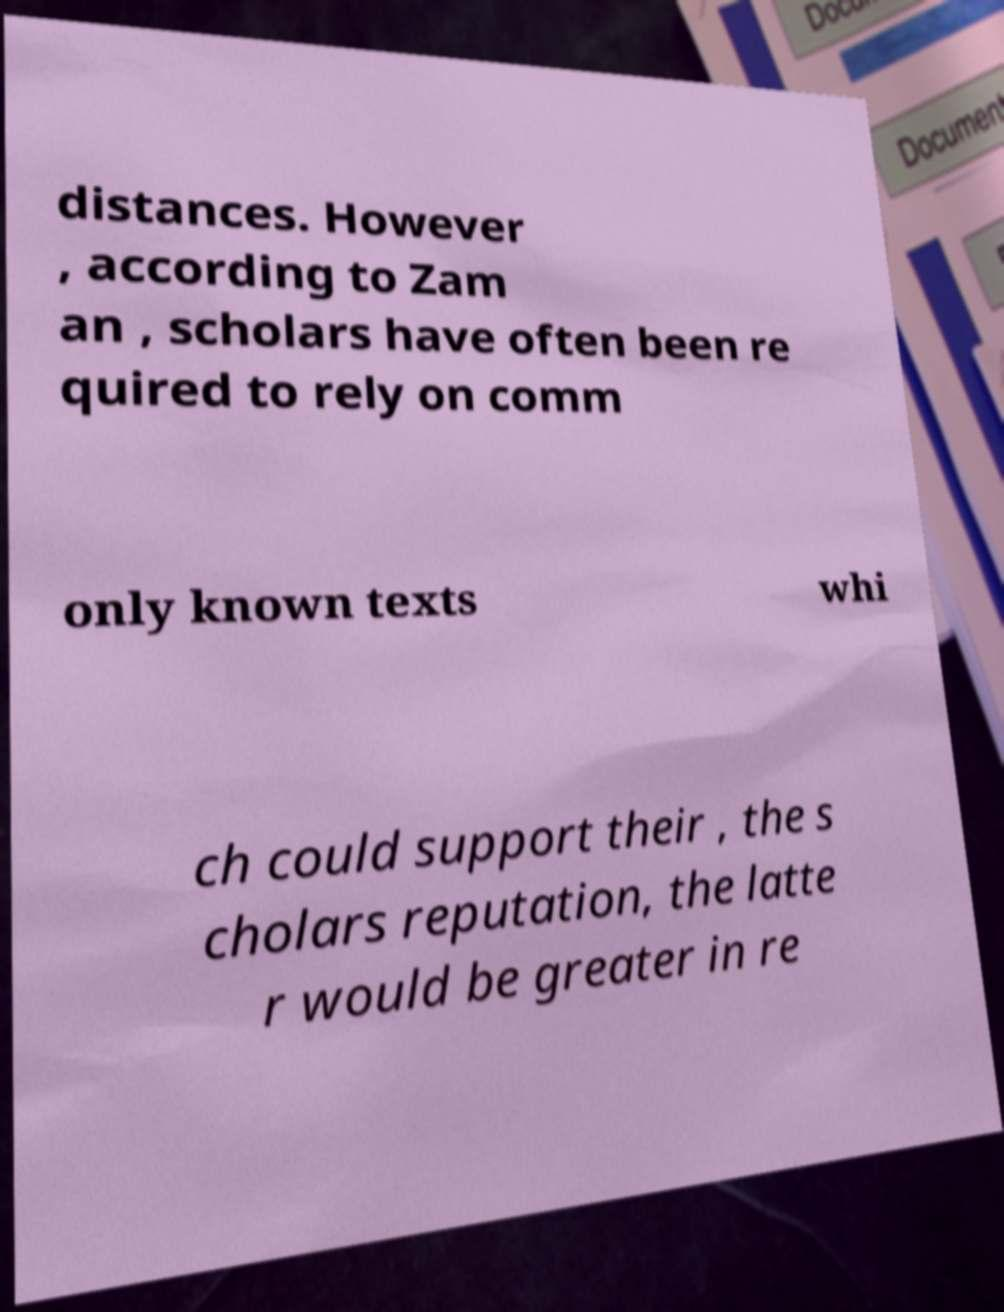Please read and relay the text visible in this image. What does it say? distances. However , according to Zam an , scholars have often been re quired to rely on comm only known texts whi ch could support their , the s cholars reputation, the latte r would be greater in re 